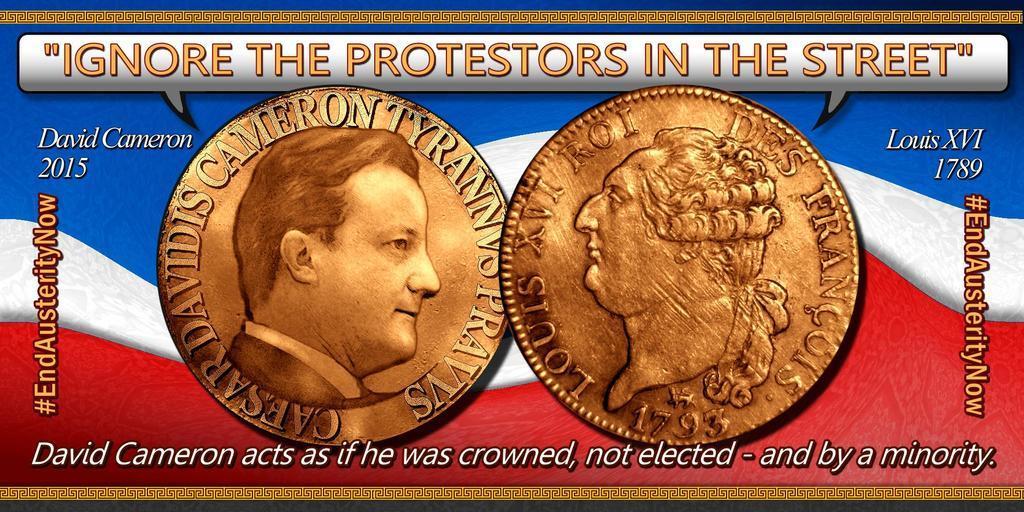Could you give a brief overview of what you see in this image? In this picture, we see a poster or a banner in blue, white and red color. We see the currency coins printed on the banner. At the top and at the bottom, we see some text written on it. 